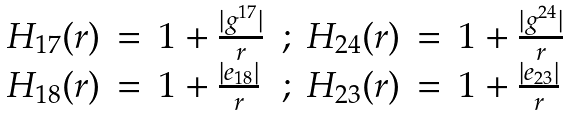<formula> <loc_0><loc_0><loc_500><loc_500>\begin{array} { r c l c r c l } H _ { 1 7 } ( r ) & = & 1 + \frac { | g ^ { 1 7 } | } { r } & ; & H _ { 2 4 } ( r ) & = & 1 + \frac { | g ^ { 2 4 } | } { r } \\ H _ { 1 8 } ( r ) & = & 1 + \frac { | e _ { 1 8 } | } { r } & ; & H _ { 2 3 } ( r ) & = & 1 + \frac { | e _ { 2 3 } | } { r } \\ \end{array}</formula> 